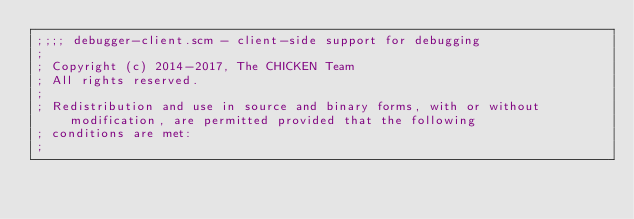Convert code to text. <code><loc_0><loc_0><loc_500><loc_500><_Scheme_>;;;; debugger-client.scm - client-side support for debugging
;
; Copyright (c) 2014-2017, The CHICKEN Team
; All rights reserved.
;
; Redistribution and use in source and binary forms, with or without modification, are permitted provided that the following
; conditions are met:
;</code> 